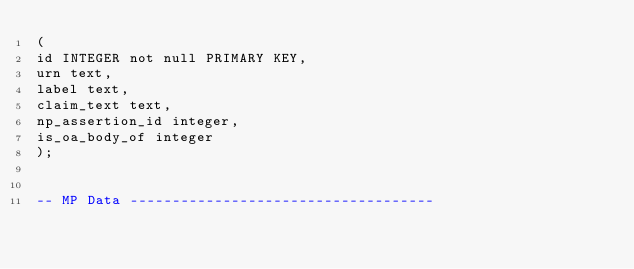<code> <loc_0><loc_0><loc_500><loc_500><_SQL_>(
id INTEGER not null PRIMARY KEY,
urn text,
label text,
claim_text text,
np_assertion_id integer,
is_oa_body_of integer
);


-- MP Data ------------------------------------</code> 